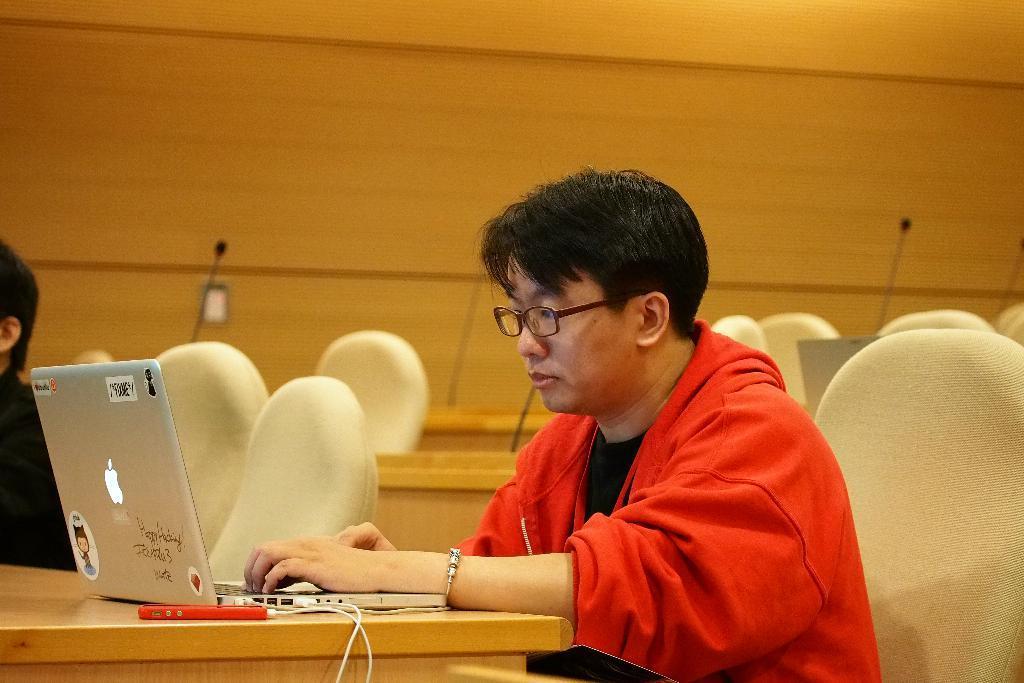In one or two sentences, can you explain what this image depicts? This image is taken indoors. In the background there is a wall. There are many empty chairs and benches. There are few mics's. In the middle of the image a man is sitting on the chair and using a laptop. On the left side of the image there is a table with a laptop on it and there is a person sitting on the chair. 